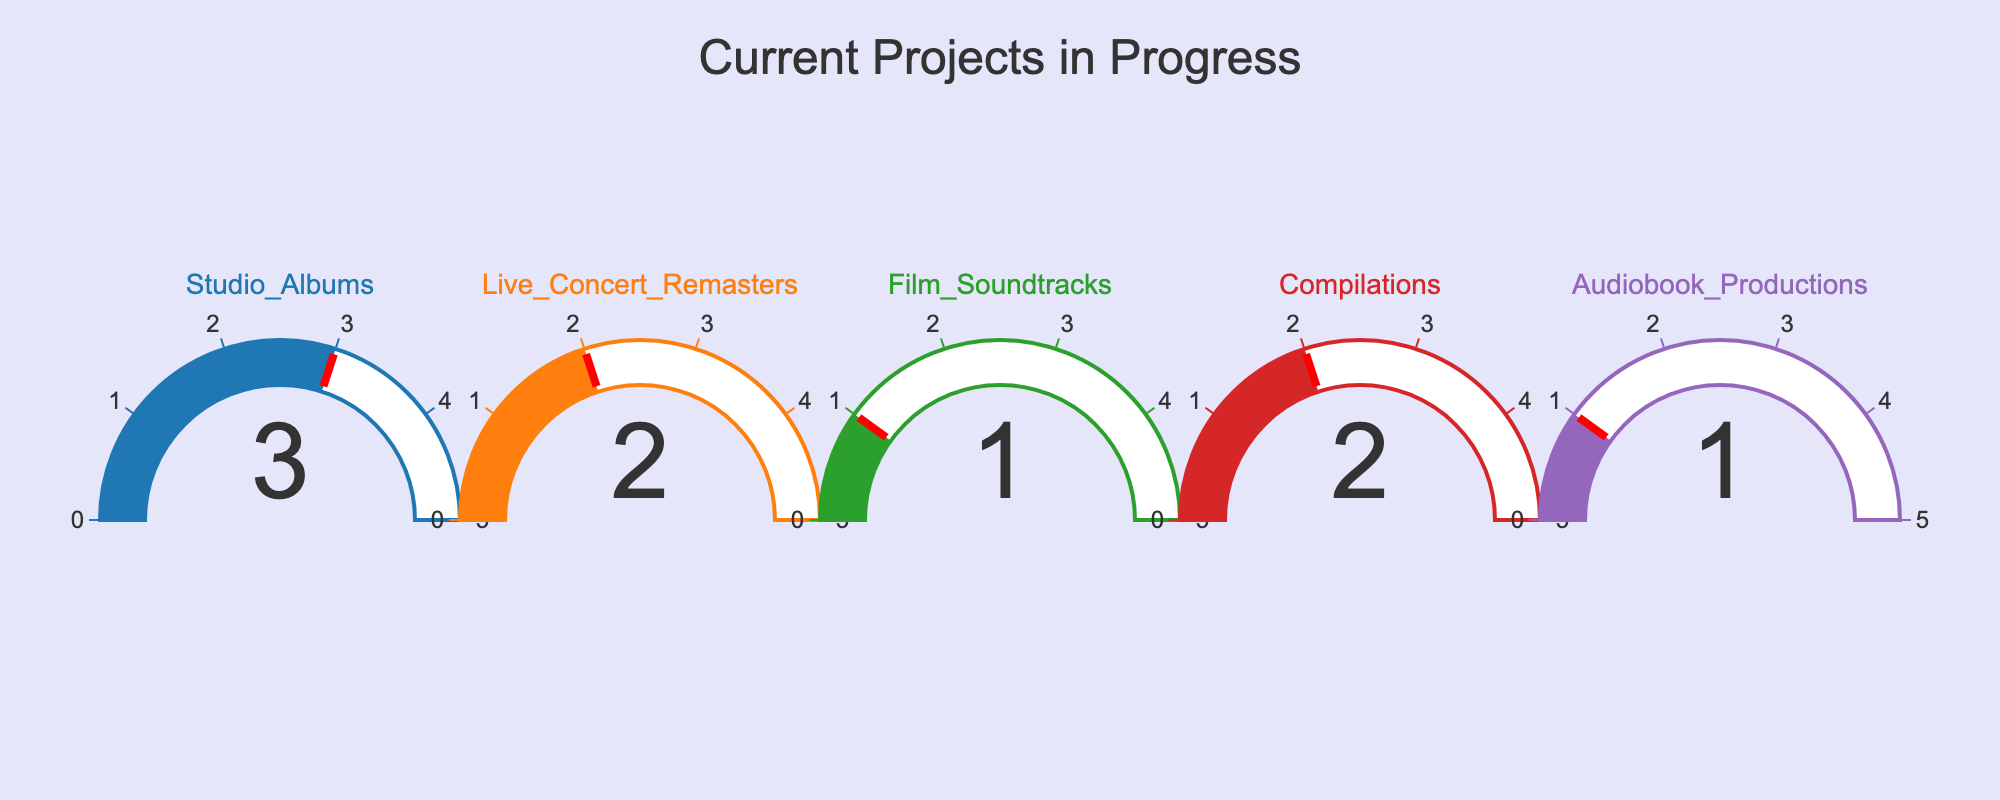Which project type has the highest number of current projects? The gauge chart shows multiple project types, each with a different number of current projects. The project type with the gauge showing the highest value is "Studio Albums" with a value of 3.
Answer: Studio Albums How many total projects are currently in progress? By summing up the values from all the gauges: (3 for Studio Albums, 2 for Live Concert Remasters, 1 for Film Soundtracks, 2 for Compilations, and 1 for Audiobook Productions), we get 3 + 2 + 1 + 2 + 1 = 9.
Answer: 9 Which project type has the fewest number of current projects? Looking at the gauge chart, "Film Soundtracks" and "Audiobook Productions" have the lowest values, each with 1 project.
Answer: Film Soundtracks, Audiobook Productions Is the number of current projects for "Compilations" greater than, less than, or equal to the number of projects for "Live Concert Remasters"? The gauge for "Compilations" shows 2 projects, and the gauge for "Live Concert Remasters" also shows 2 projects. Since both gauges show the same value, they are equal.
Answer: Equal What is the average number of current projects per project type? Calculate the average by dividing the total number of projects by the number of project types. The total is 9 projects over 5 project types, so 9 / 5 = 1.8.
Answer: 1.8 How many more projects are there for "Studio Albums" compared to "Film Soundtracks"? "Studio Albums" has 3 projects, while "Film Soundtracks" has 1 project. The difference is 3 - 1 = 2.
Answer: 2 What is the combined number of projects for "Studio Albums" and "Live Concert Remasters"? Adding the projects for these two types: 3 (Studio Albums) + 2 (Live Concert Remasters) = 5.
Answer: 5 Do any of the gauges show a value of 4 or higher? Evaluating each gauge individually, the highest value displayed is 3, so no gauge shows a value of 4 or higher.
Answer: No Which projects form a group that collectively has an equal number of current projects as the "Studio Albums"? "Studio Albums" has 3 projects. The project types "Film Soundtracks" and "Compilations" combined have 1 + 2 = 3 projects, which equals the number for "Studio Albums".
Answer: Film Soundtracks and Compilations 